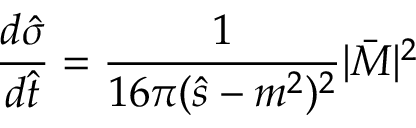<formula> <loc_0><loc_0><loc_500><loc_500>\frac { d \hat { \sigma } } { d \hat { t } } = \frac { 1 } { 1 6 \pi ( \hat { s } - m ^ { 2 } ) ^ { 2 } } | \bar { M } | ^ { 2 }</formula> 